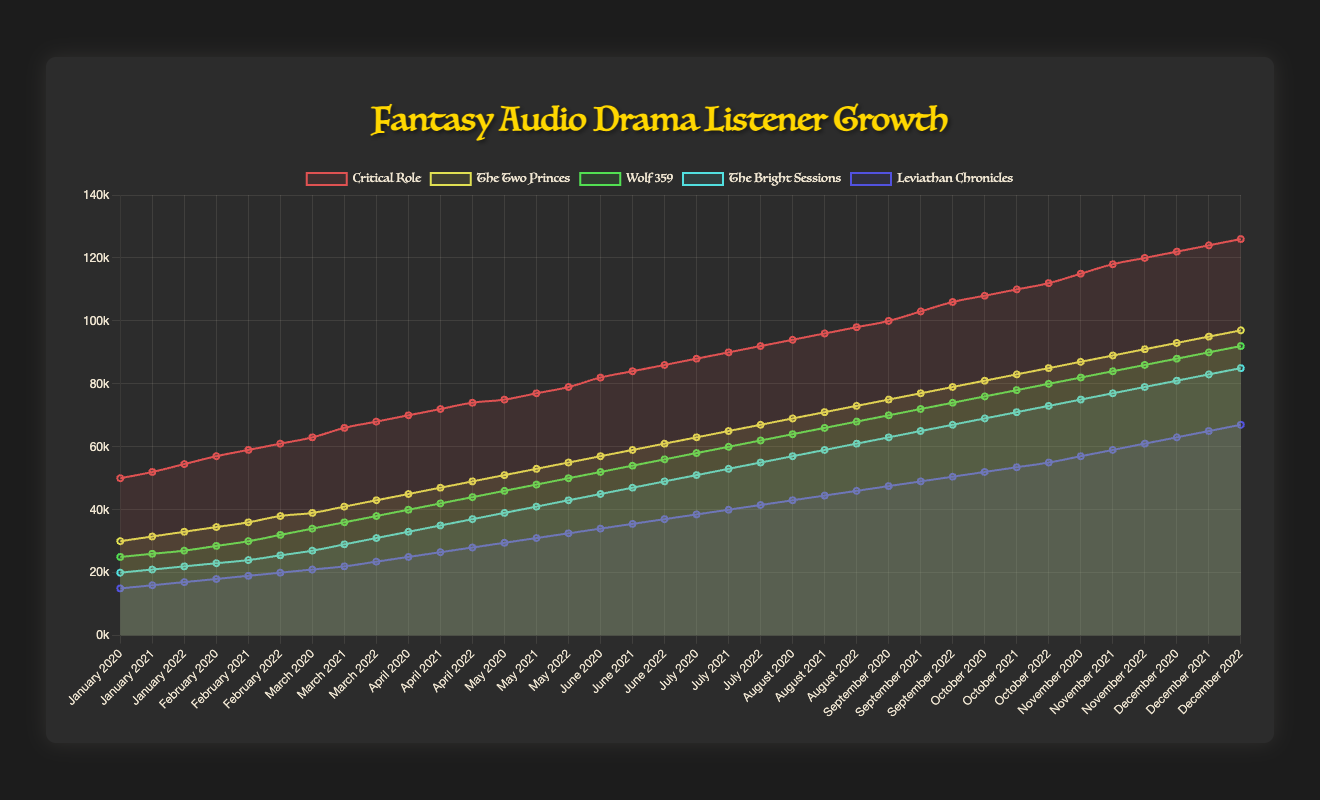What is the total number of listeners for "Critical Role" in 2020? Look at the 2020 values for "Critical Role": sum all the monthly listeners (50000 + 52000 + 54500 + 57000 + 59000 + 61000 + 63000 + 66000 + 68000 + 70000 + 72000 + 74000). The total sum is 736500.
Answer: 736500 Which audio drama had the greatest listener growth between January 2020 and December 2022? Look at the listener numbers in January 2020 and December 2022 for all dramas. "Critical Role" grows from 50000 to 126000, "The Two Princes" from 30000 to 97000, "Wolf 359" from 25000 to 92000, "The Bright Sessions" from 20000 to 85000, and "Leviathan Chronicles" from 15000 to 67000. "Critical Role" has the greatest growth (126000-50000=76000).
Answer: Critical Role What pattern do you see for listener growth in "The Bright Sessions" over the years? Track the general direction and rate of the "The Bright Sessions" line from 2020 to 2022. It shows a consistent increase in listeners each year. In 2020 it starts at 20000 and ends at 37000, in 2021 it climbs to 61000, and in 2022 peaks at 85000. This consistent pattern indicates steady growth.
Answer: Consistent increase Comparing "Wolf 359" and "Leviathan Chronicles", which had more listeners in June 2021? Look at June 2021 values for both. "Wolf 359" has 56000 listeners in June 2021, while "Leviathan Chronicles" has 37000. Therefore, "Wolf 359" had more listeners in that month.
Answer: Wolf 359 How did the number of listeners for "The Two Princes" change from March to August 2021? Look at the listener count for March and August in 2021 for "The Two Princes". In March, it has 55000 listeners and in August it has 65000. The change is an increase of (65000 - 55000) = 10000.
Answer: Increased by 10000 By what percentage did the listeners of "Critical Role" grow from the beginning to the end of 2021? Look at the listener numbers in January and December 2021. January has 75000 and December has 98000. The growth is (98000 - 75000) = 23000. To find the percentage growth: (23000 / 75000) * 100 ≈ 30.67%.
Answer: 30.67% Which audio drama had the smallest number of listeners in December 2022? Look at the listener values for all dramas in December 2022. "Leviathan Chronicles" has 67000 listeners, which is the smallest compared to the others.
Answer: Leviathan Chronicles On average, how many listeners did "The Bright Sessions" gain per month in 2020? Look at the listener counts for each month in 2020 and find the total gain from January to December (37000 - 20000 = 17000). There are 11 intervals between 12 months, so average monthly gain is 17000 / 11 ≈ 1545.45.
Answer: 1545.45 